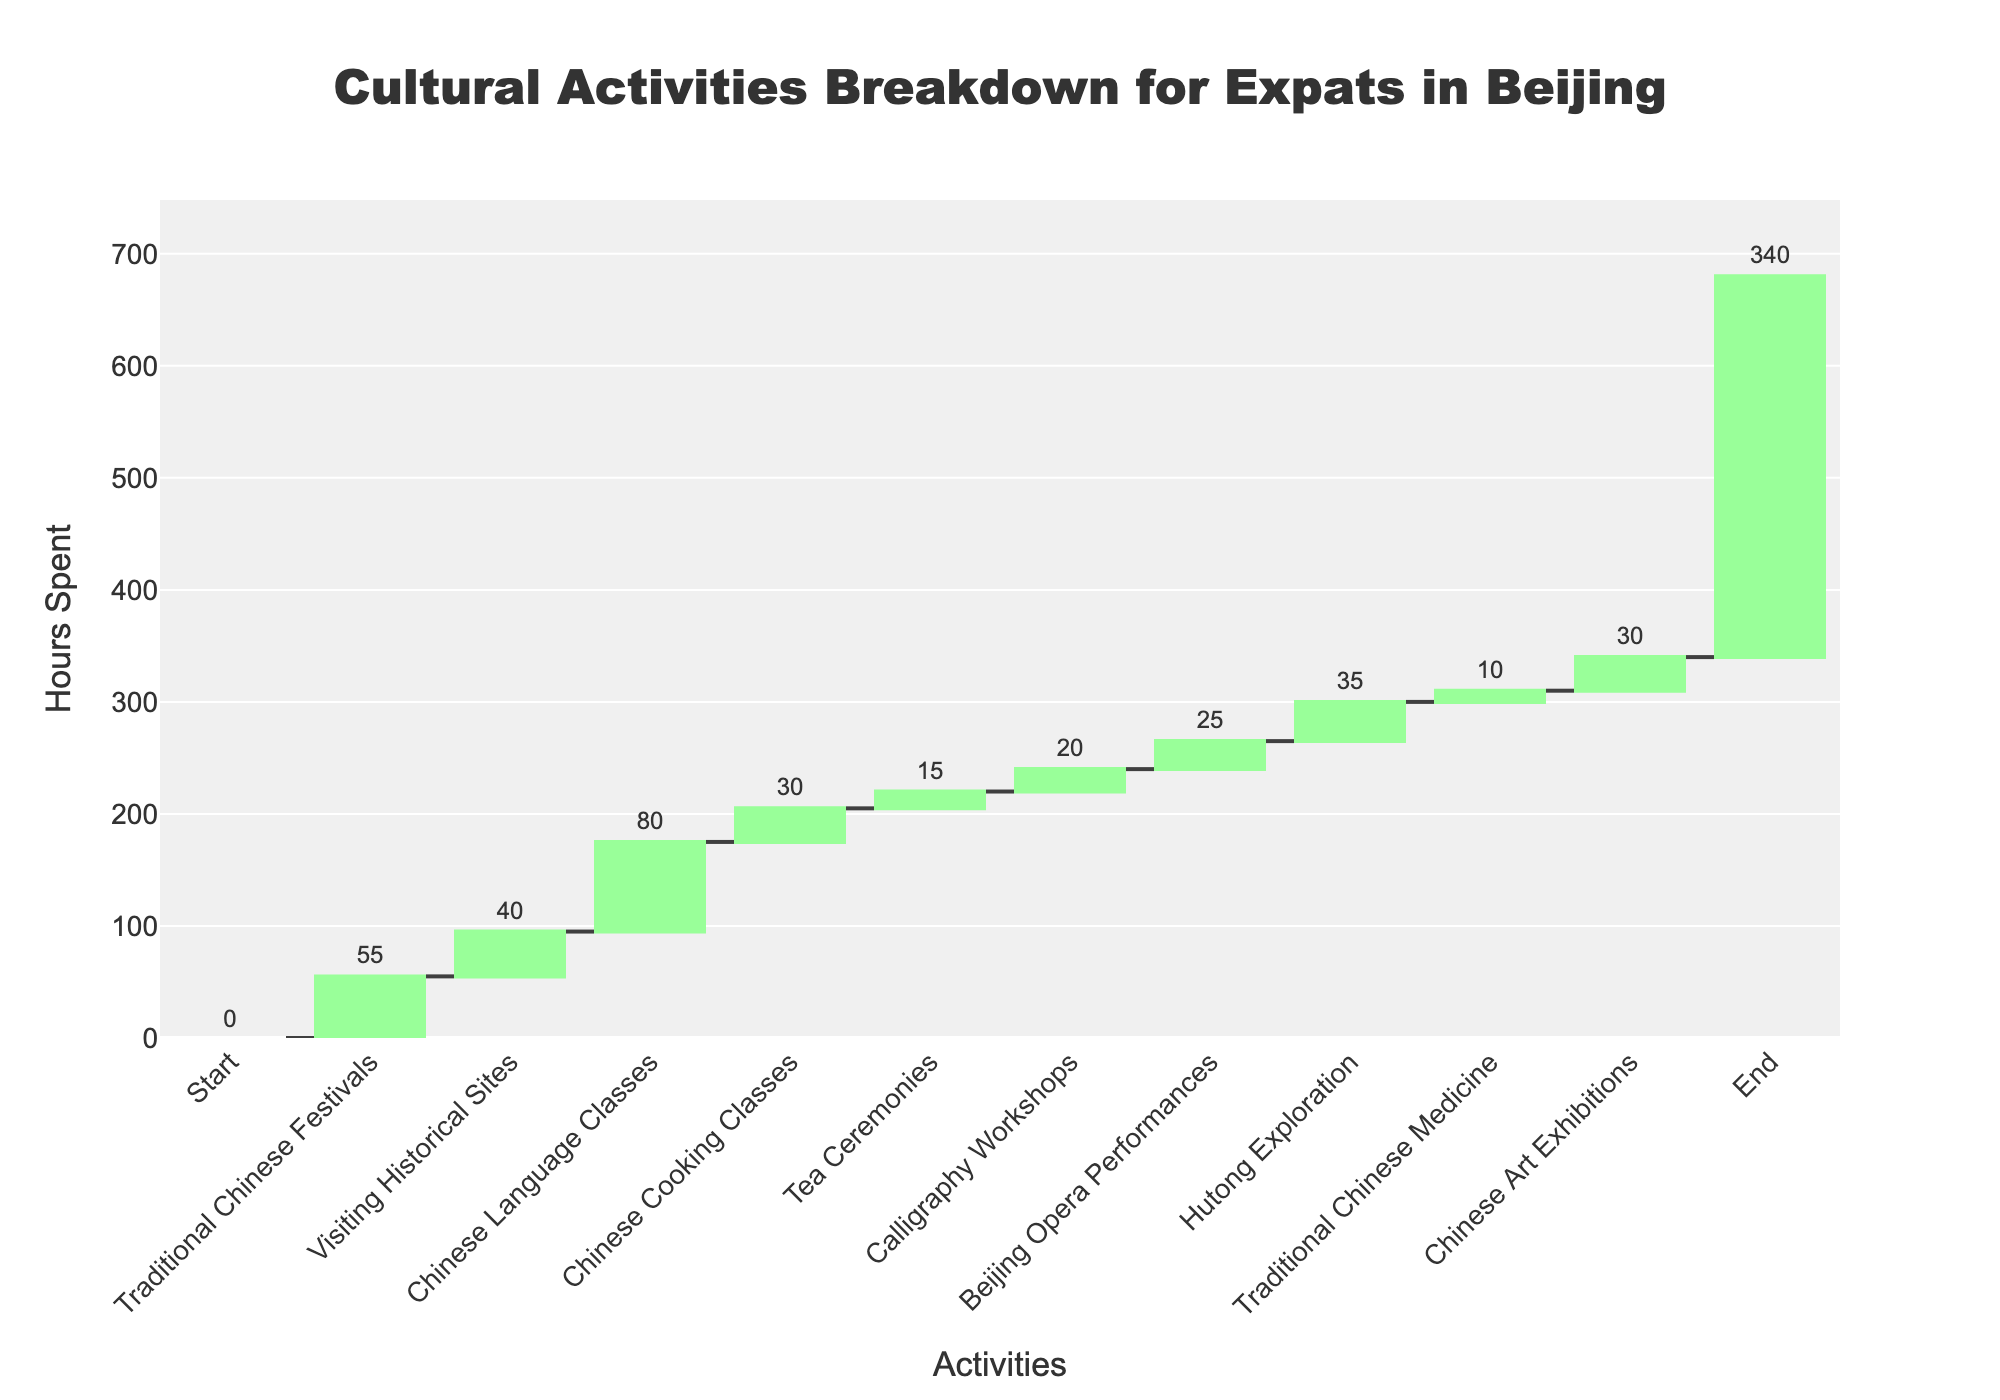What is the total number of hours spent on cultural activities as shown in the figure? To find the total time, look at the final cumulative value listed at the end of the chart, which represents the sum of all hours of activities shown.
Answer: 340 How many hours were spent on Chinese Language Classes? Look for the bar labeled "Chinese Language Classes" and check the value outside the bar.
Answer: 80 What is the difference in hours between Visiting Historical Sites and Hutong Exploration? Find the hours for both activities: Visiting Historical Sites (40) and Hutong Exploration (35). Subtract the smaller number from the larger. 40 - 35 = 5.
Answer: 5 Which two activities combined take the longest time, and what is their total? Identify the two activities with the longest hours. The top two are Chinese Language Classes (80) and Traditional Chinese Festivals (55). Sum these two amounts. 80 + 55 = 135.
Answer: Chinese Language Classes and Traditional Chinese Festivals, 135 What is the percentage of time spent on Calligraphy Workshops relative to the total hours? Use the total hours (340) and hours spent on Calligraphy Workshops (20). Calculate the percentage using the formula (20 / 340) * 100 = 5.88%.
Answer: 5.88% Which activity has the least amount of hours spent? Look for the activity bar with the smallest value. Tea Ceremonies is the activity with the least hours (15).
Answer: Tea Ceremonies How much more time is spent on Beijing Opera Performances compared to Traditional Chinese Medicine? Find the hours for both activities: Beijing Opera Performances (25) and Traditional Chinese Medicine (10). Subtract the smaller number from the larger. 25 - 10 = 15.
Answer: 15 What is the average number of hours spent on Traditional Chinese Festivals, Hutong Exploration, and Chinese Art Exhibitions? Sum the hours for these activities: Traditional Chinese Festivals (55), Hutong Exploration (35), and Chinese Art Exhibitions (30). Then divide by 3. (55 + 35 + 30) / 3 = 40.
Answer: 40 